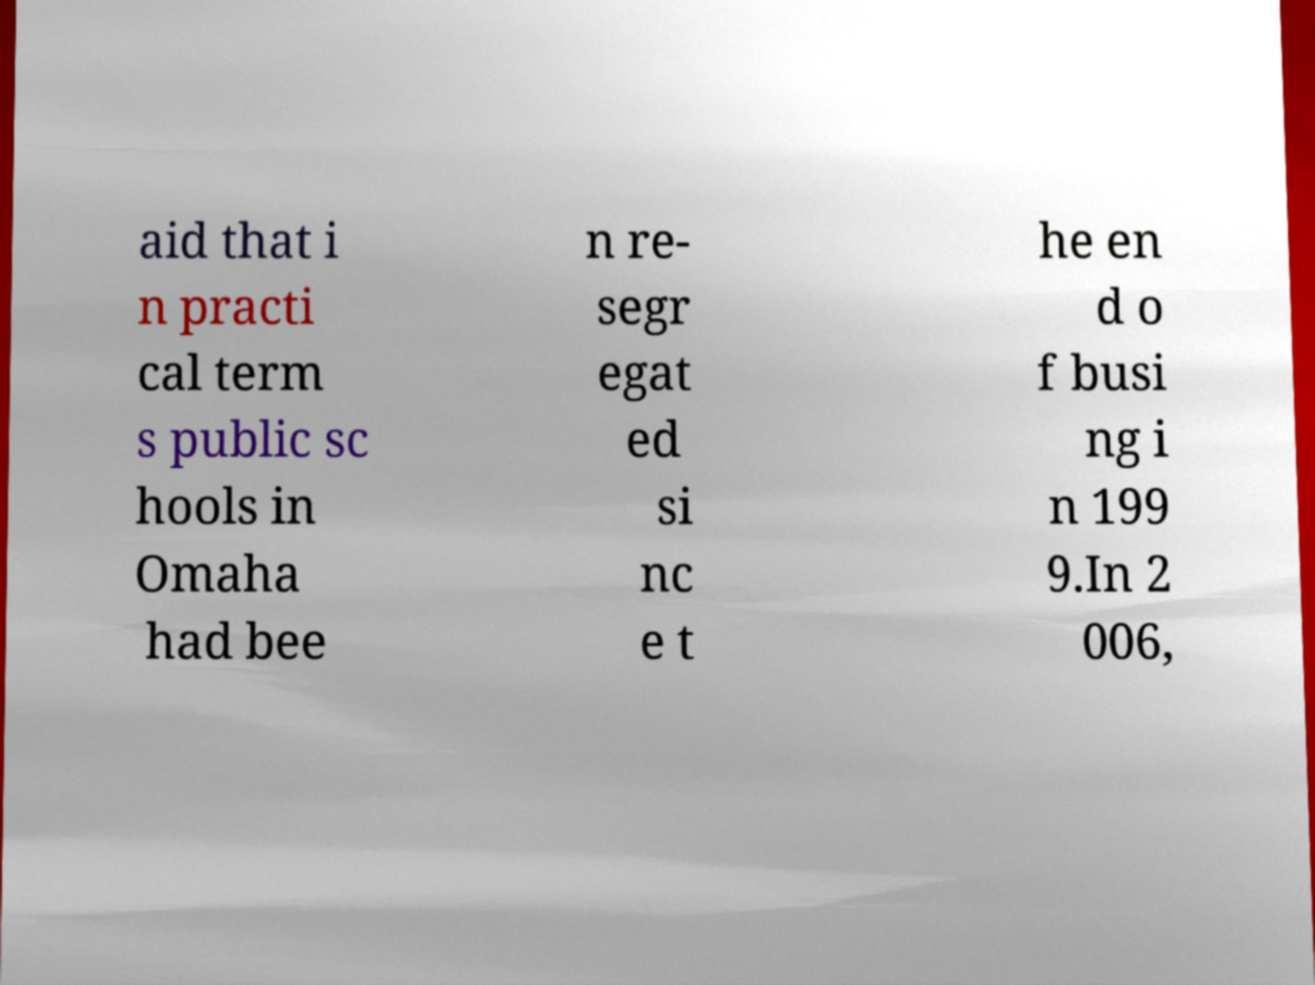Can you read and provide the text displayed in the image?This photo seems to have some interesting text. Can you extract and type it out for me? aid that i n practi cal term s public sc hools in Omaha had bee n re- segr egat ed si nc e t he en d o f busi ng i n 199 9.In 2 006, 